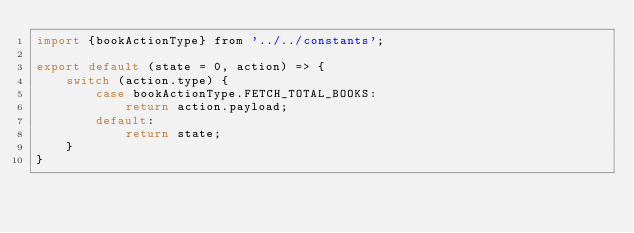Convert code to text. <code><loc_0><loc_0><loc_500><loc_500><_JavaScript_>import {bookActionType} from '../../constants';

export default (state = 0, action) => {
    switch (action.type) {
        case bookActionType.FETCH_TOTAL_BOOKS:
            return action.payload;
        default:
            return state;
    }
}
</code> 